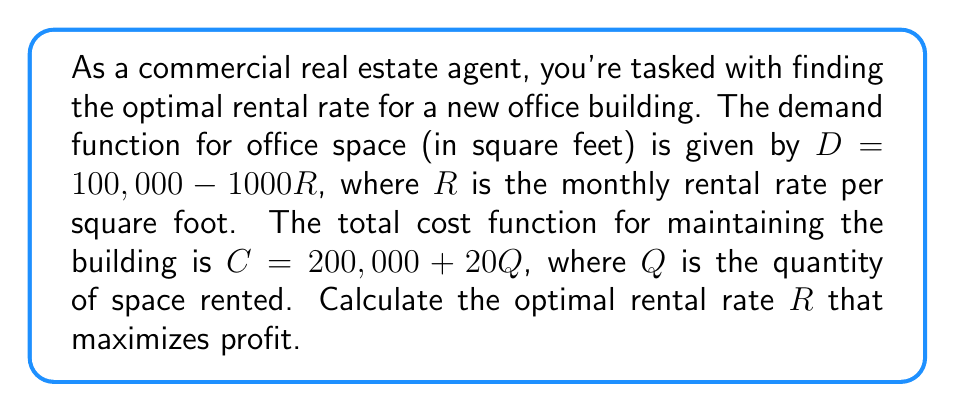Can you solve this math problem? 1) First, we need to formulate the profit function. Profit (P) = Revenue (R) - Cost (C)

2) Revenue = Price × Quantity
   $R \times Q = R \times (100,000 - 1000R)$

3) Cost = $200,000 + 20Q = 200,000 + 20(100,000 - 1000R)$

4) Profit function:
   $P = R(100,000 - 1000R) - [200,000 + 20(100,000 - 1000R)]$
   $P = 100,000R - 1000R^2 - 200,000 - 2,000,000 + 20,000R$
   $P = 120,000R - 1000R^2 - 2,200,000$

5) To maximize profit, we find where $\frac{dP}{dR} = 0$:
   $\frac{dP}{dR} = 120,000 - 2000R$

6) Set this equal to zero and solve:
   $120,000 - 2000R = 0$
   $120,000 = 2000R$
   $R = 60$

7) Verify this is a maximum by checking the second derivative:
   $\frac{d^2P}{dR^2} = -2000 < 0$, confirming a maximum.

Therefore, the optimal rental rate is $60 per square foot.
Answer: $60 per square foot 